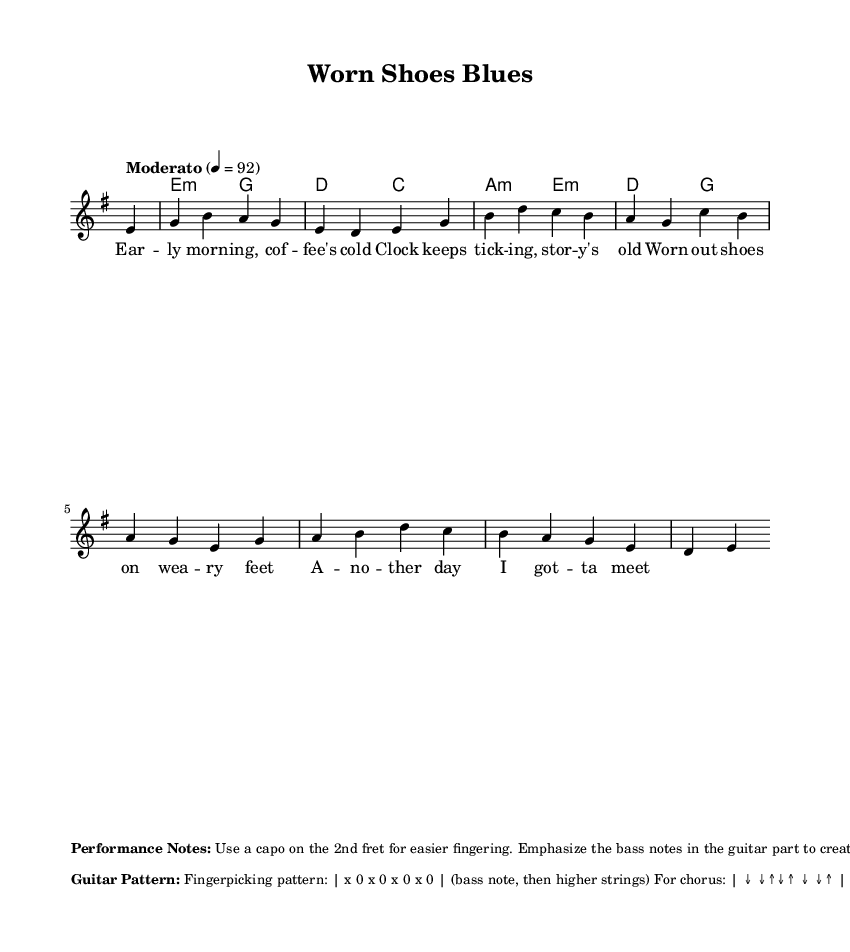What is the key signature of this music? The key signature is indicated by the number of sharps or flats at the beginning. In this case, it shows an E minor key signature, which has one sharp (F#) and is noted as "e minor."
Answer: E minor What is the time signature of this piece? The time signature is the number written at the beginning of the staff, indicating the number of beats per measure. Here, it is shown as 4 over 4, meaning there are four beats in each measure.
Answer: 4/4 What is the tempo marking for this piece? The tempo marking is typically specified in words at the beginning of the piece, indicating the speed. In this sheet music, the tempo is marked as "Moderato," which indicates a moderate speed.
Answer: Moderato What chord appears most frequently in the harmonies? By reviewing the chord progression provided, the chord "E minor" appears multiple times in the sequence, as it starts off and repeats in the harmonies throughout the piece.
Answer: E minor How many lines of lyrics are provided in this piece? The lyrics are printed below the melody, and by counting them, there are four distinct lines of lyrics provided in the verse.
Answer: Four What kind of tone should the vocals be delivered in? The performance notes specify that the vocals should be delivered with a "rough, world-weary tone," which aligns with the blues genre's expression of struggle and hardship.
Answer: Rough, world-weary What guitar technique is emphasized in the performance notes? The performance notes mention "fingerpicking" as the technique, specifically indicating a pattern that starts with the bass note, suggesting a focus on this style to provide rhythm and depth.
Answer: Fingerpicking 